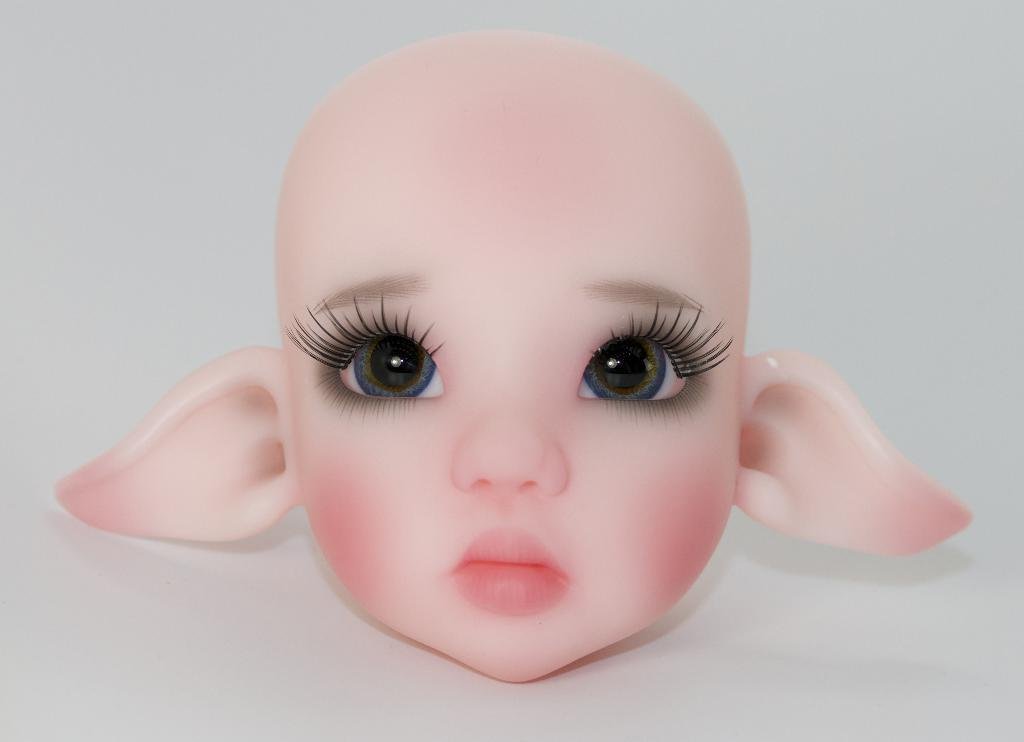What is the main subject of the picture? The main subject of the picture is a toy head. How many eyes does the toy head have? The toy head has two eyes. What other facial features does the toy head have? The toy head has two ears, a nose, and a mouth. What color are the toy head's cheeks? The toy head has pink cheeks. What is the background color in the picture? The background in the picture is white. What type of calendar is visible in the picture? There is no calendar present in the picture; it features a toy head with various facial features. What are the people protesting about in the picture? There is no protest or any indication of people in the picture; it only shows a toy head. 